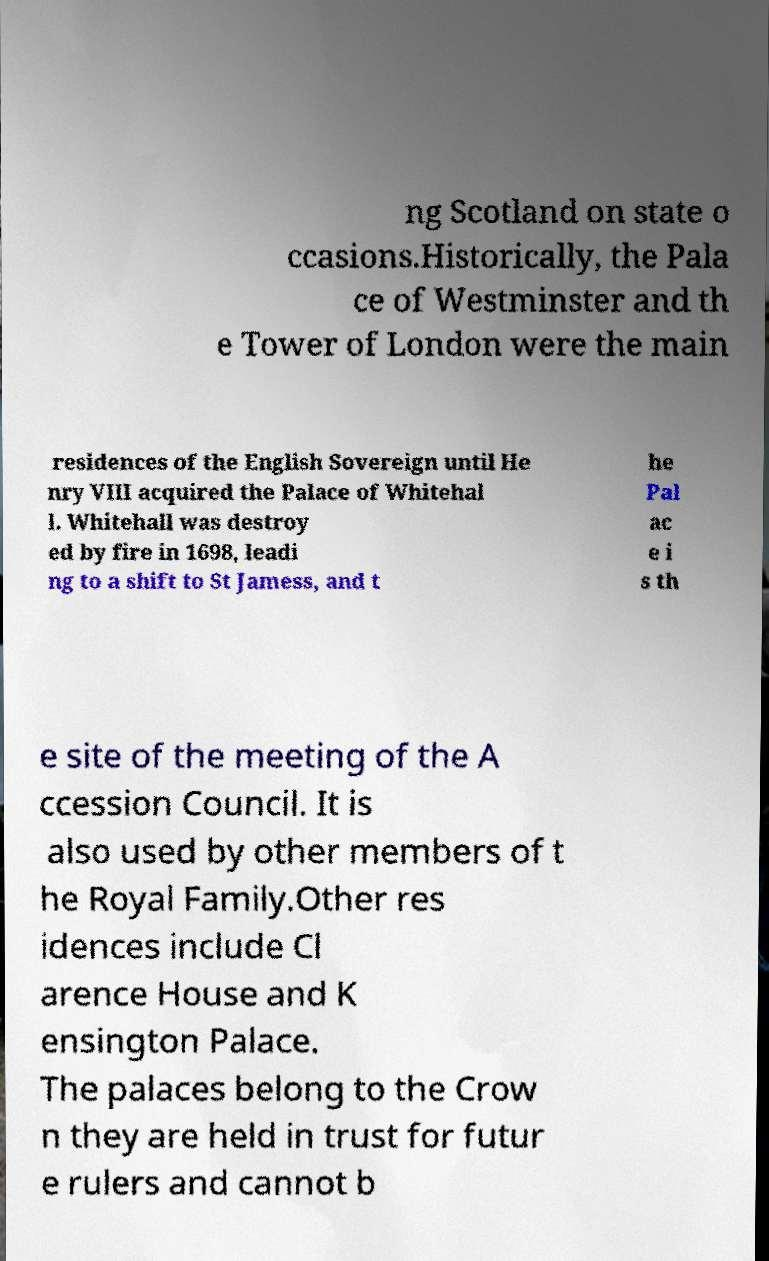There's text embedded in this image that I need extracted. Can you transcribe it verbatim? ng Scotland on state o ccasions.Historically, the Pala ce of Westminster and th e Tower of London were the main residences of the English Sovereign until He nry VIII acquired the Palace of Whitehal l. Whitehall was destroy ed by fire in 1698, leadi ng to a shift to St Jamess, and t he Pal ac e i s th e site of the meeting of the A ccession Council. It is also used by other members of t he Royal Family.Other res idences include Cl arence House and K ensington Palace. The palaces belong to the Crow n they are held in trust for futur e rulers and cannot b 